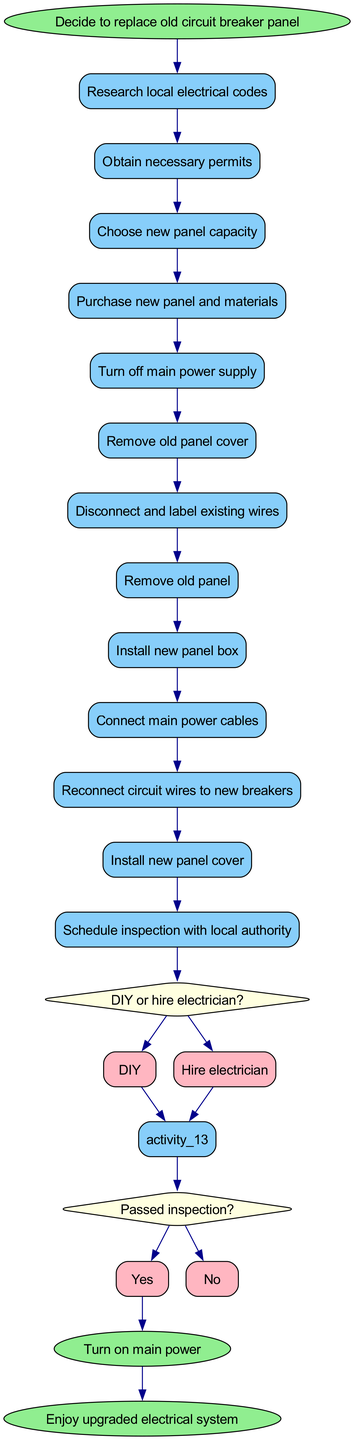What is the starting activity in the diagram? The starting activity is labeled as the 'start' node, which leads to the first action taken in the process. Looking at the diagram, the node immediately after the start is "Decide to replace old circuit breaker panel."
Answer: Decide to replace old circuit breaker panel How many activities are listed in the diagram? By counting the nodes labeled as activities, we can see that there are a total of thirteen activities listed in the diagram. Each activity is represented as a rectangle.
Answer: 13 What decision is made after the activity "Remove old panel"? Following the activity "Remove old panel," the next node represents a decision point asking "DIY or hire electrician?" which determines the subsequent steps based on whether one chooses to do it themselves or hire a professional.
Answer: DIY or hire electrician What flows from the decision "DIY or hire electrician" if the option 'Hire electrician' is chosen? When 'Hire electrician' is selected, the flow leads to the next activity where the electrician will continue the process. This option is connected to "Install new panel box," as the option directs the timeline towards professional installation.
Answer: Install new panel box What is the last activity mentioned in the diagram before the end nodes? The last activity in the diagram before transitioning to the end nodes is "Reconnect circuit wires to new breakers." The activities are followed by decision points and end nodes, but this is the final activity that completes the long sequence of actions.
Answer: Reconnect circuit wires to new breakers If the inspection fails, what happens next according to the flow? If the inspection fails, the flow does not indicate a specific next step, and then the process would typically revert back to addressing issues until passing inspection. Since this route is not explicitly captured in the diagram, it's inferred that you would need to repeat actions until compliant.
Answer: Repeat actions How does the diagram conclude after all activities? The process concludes after performing all prescribed activities and making necessary connections. Finally, there are two end nodes indicating the transition to "Turn on main power" and "Enjoy upgraded electrical system," completing the circuit panel replacement.
Answer: Turn on main power, Enjoy upgraded electrical system 